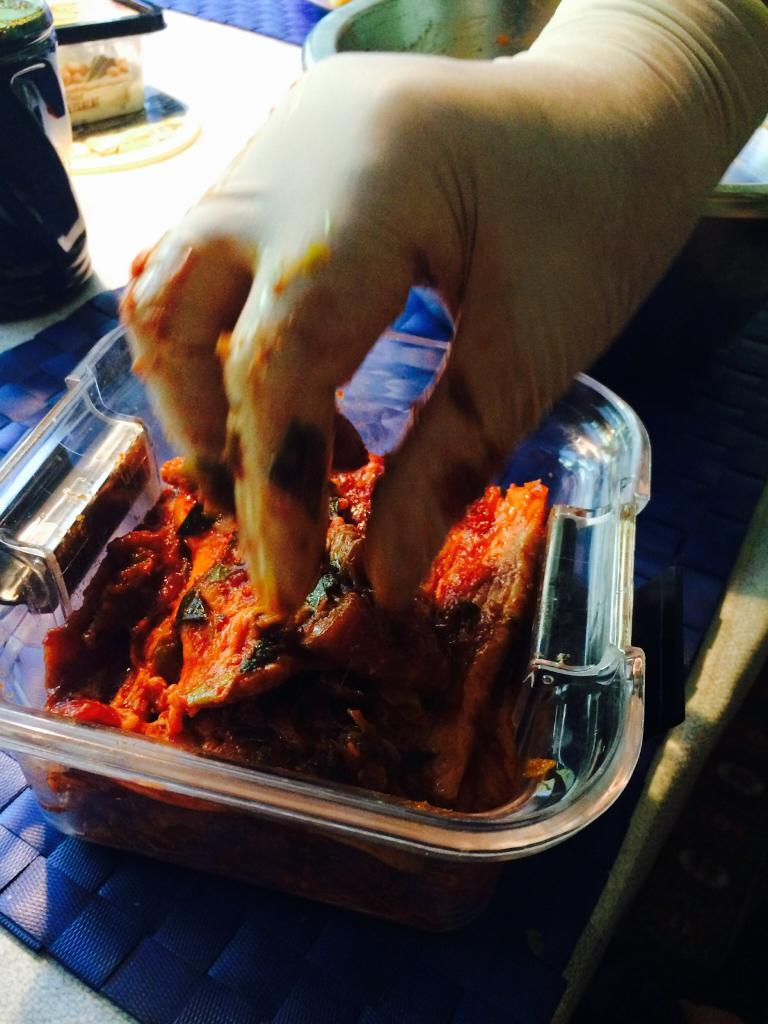Who is present in the image? There is a person in the image. What is the person holding in the image? The person is holding food in the image. How is the food being stored or carried? The food is placed in a container in the image. Where is the container located? The container is on a table in the image. What type of argument is taking place between the person and the spoon in the image? There is no spoon present in the image, and therefore no argument can be observed. 